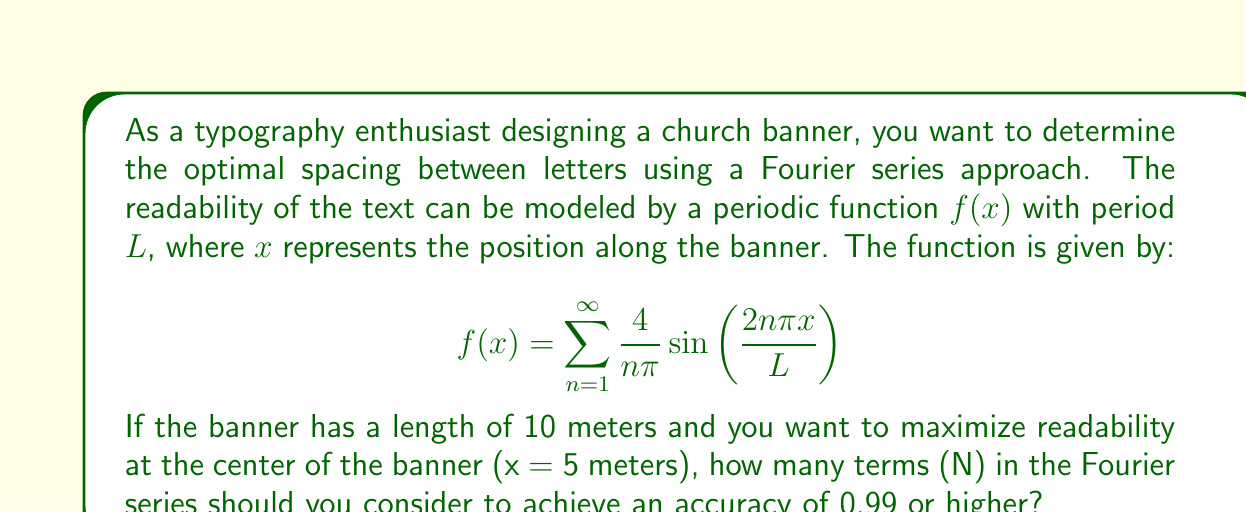Provide a solution to this math problem. To solve this problem, we need to follow these steps:

1) The readability function is given by a Fourier sine series:

   $$f(x) = \sum_{n=1}^{\infty} \frac{4}{n\pi} \sin\left(\frac{2n\pi x}{L}\right)$$

2) We want to maximize readability at the center of the banner, which is at x = 5 meters (given L = 10 meters).

3) Substituting these values:

   $$f(5) = \sum_{n=1}^{\infty} \frac{4}{n\pi} \sin\left(\frac{2n\pi \cdot 5}{10}\right) = \sum_{n=1}^{\infty} \frac{4}{n\pi} \sin(n\pi)$$

4) Note that $\sin(n\pi) = 0$ for even n, and $(-1)^{(n-1)/2}$ for odd n.

5) Therefore, our series becomes:

   $$f(5) = \sum_{n=1, n \text{ odd}}^{\infty} \frac{4}{n\pi} (-1)^{(n-1)/2}$$

6) This is an alternating series. The exact sum of this series is 1.

7) To find how many terms we need for 0.99 accuracy, we can use the alternating series estimation theorem. We need to find N such that:

   $$\left|\frac{4}{(N+2)\pi}\right| \leq 0.01$$

8) Solving this inequality:

   $$\frac{4}{(N+2)\pi} \leq 0.01$$
   $$N+2 \geq \frac{400}{\pi}$$
   $$N \geq \frac{400}{\pi} - 2 \approx 125.33$$

9) Since N must be an odd integer, we round up to the next odd number.
Answer: The number of terms (N) in the Fourier series to achieve an accuracy of 0.99 or higher is 127. 